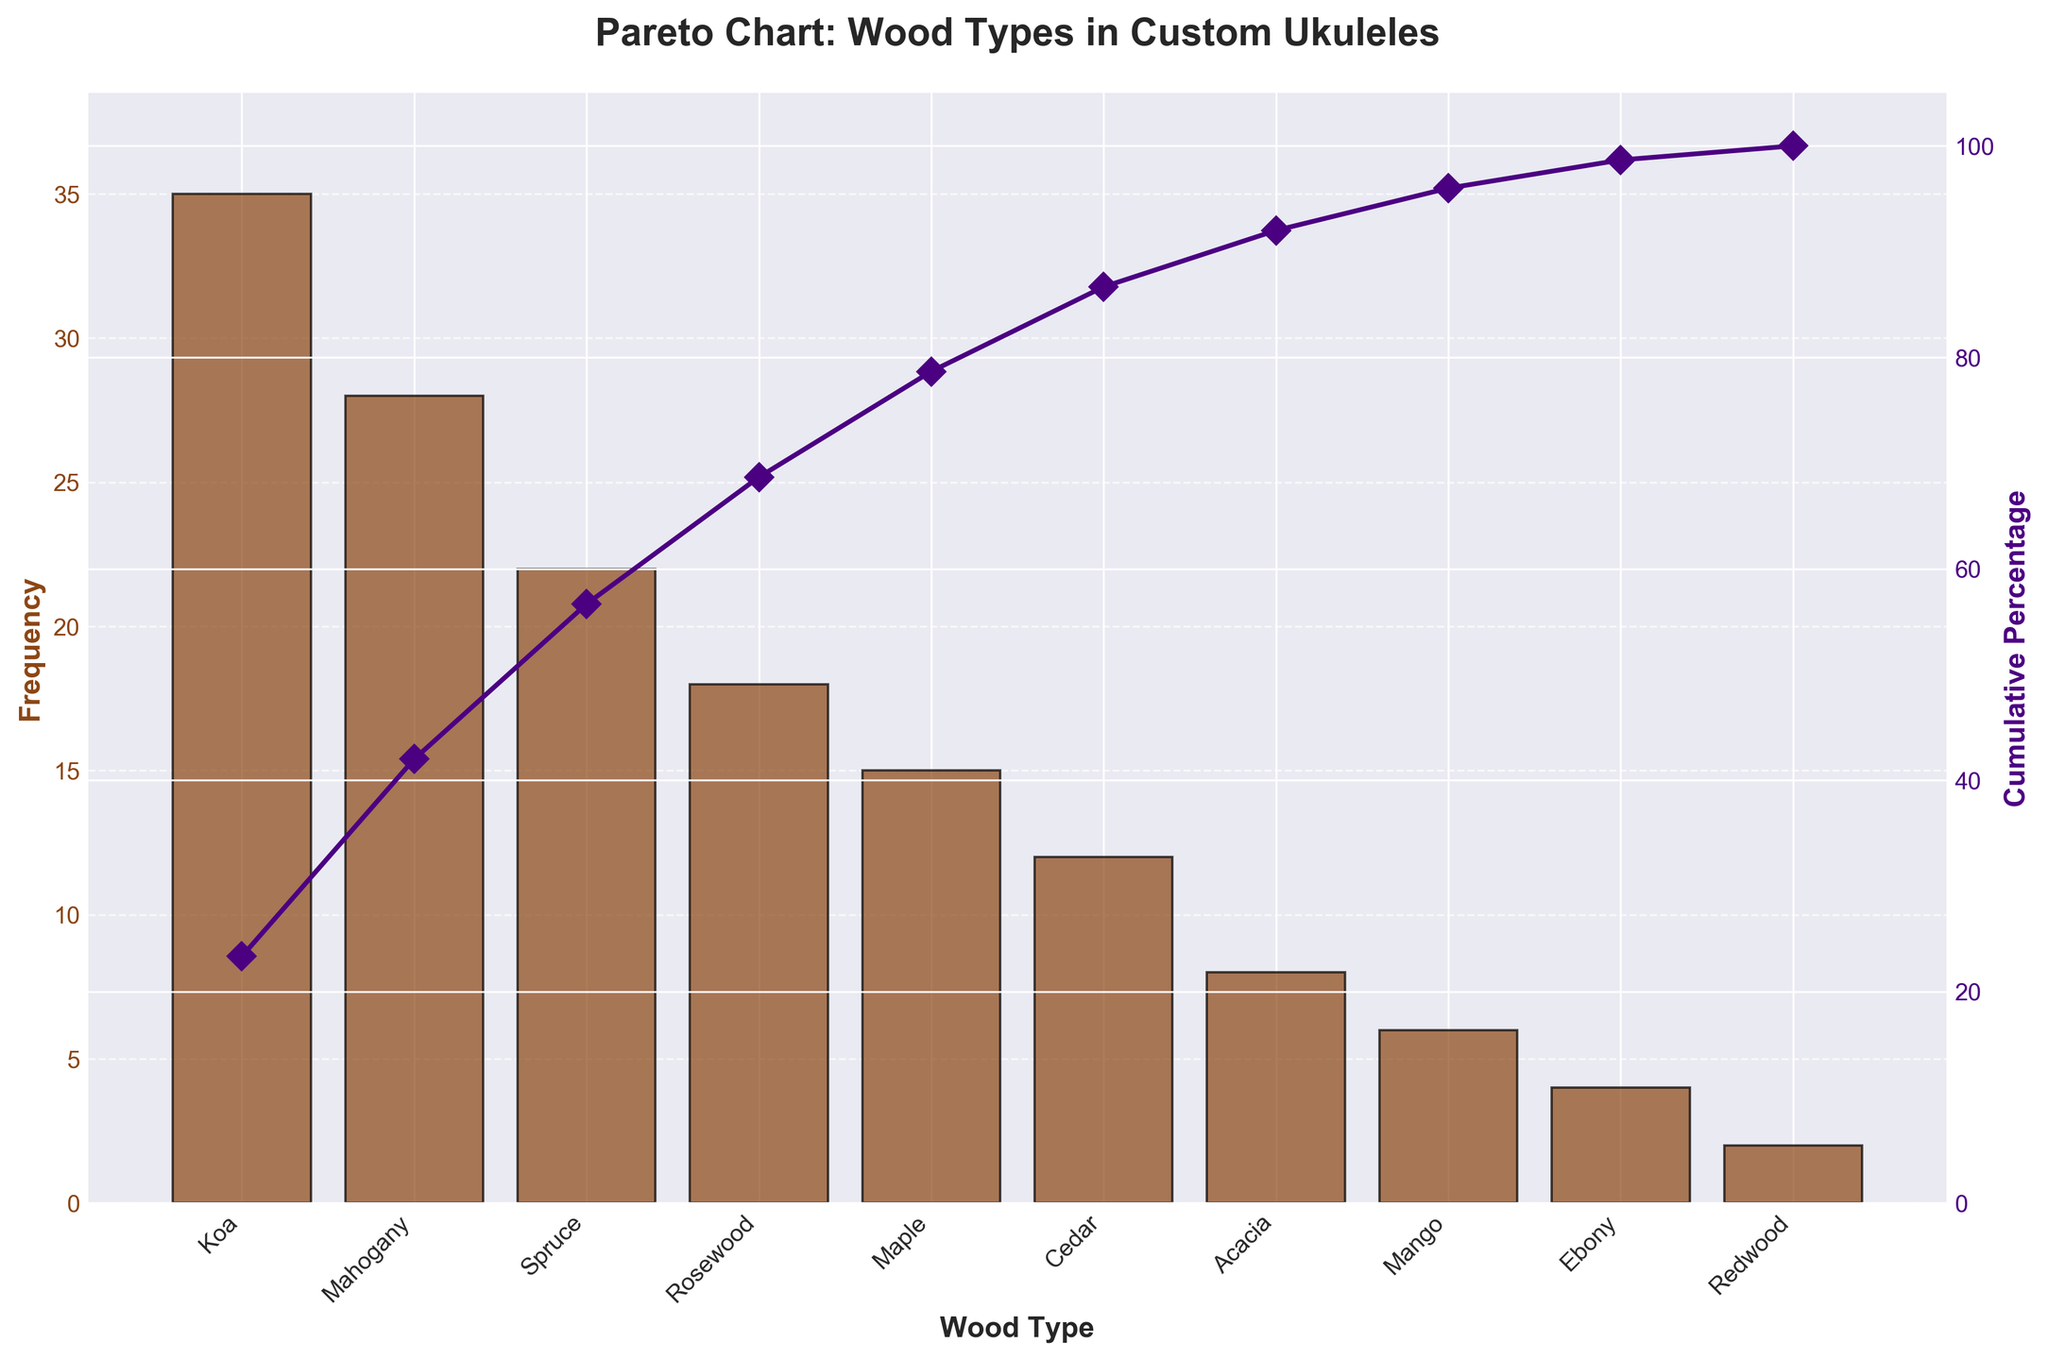What is the title of the chart? The title is usually located at the top of the chart and it reads as: 'Pareto Chart: Wood Types in Custom Ukuleles'.
Answer: Pareto Chart: Wood Types in Custom Ukuleles Which wood type is used the most frequently in custom ukuleles? The wood type with the highest bar in the chart is Koa.
Answer: Koa What is the frequency of Spruce wood used in custom ukuleles? Looking at the height of the Spruce bar on the frequency axis (y-axis), it is marked as 22.
Answer: 22 What percentage of ukuleles are made using the top two most popular wood types? First, sum the frequencies of Koa and Mahogany (35 + 28 = 63). Then, calculate the percentage relative to the total sum of frequencies (63 / 150 * 100 = 42%).
Answer: 42% Which wood types have a cumulative percentage of 70% or more? By tracing the cumulative percentage line, we see that Koa, Mahogany, Spruce, and Rosewood combine to cross the 70% cumulative percentage mark.
Answer: Koa, Mahogany, Spruce, Rosewood Which wood type contributes just under 50% to the cumulative percentage? Observing the cumulative percentage line, Mahogany lies just below the 50% mark.
Answer: Mahogany What is the total frequency of all the wood types combined? Add up all the frequencies: 35 (Koa) + 28 (Mahogany) + 22 (Spruce) + 18 (Rosewood) + 15 (Maple) + 12 (Cedar) + 8 (Acacia) + 6 (Mango) + 4 (Ebony) + 2 (Redwood) = 150.
Answer: 150 How many wood types have a frequency lower than 10? The wood types Acacia (8), Mango (6), Ebony (4), and Redwood (2) each have a frequency lower than 10.
Answer: 4 Which two wood types combine to make up the smallest percentage of custom ukuleles? The two wood types with the lowest frequencies are Redwood (2) and Ebony (4); combining these gives 6, the smallest percentage when compared to others.
Answer: Redwood, Ebony 